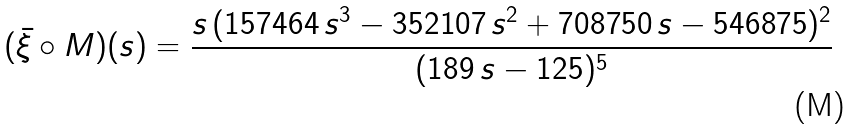Convert formula to latex. <formula><loc_0><loc_0><loc_500><loc_500>( \bar { \xi } \circ M ) ( s ) = \frac { s \, ( 1 5 7 4 6 4 \, s ^ { 3 } - 3 5 2 1 0 7 \, s ^ { 2 } + 7 0 8 7 5 0 \, s - 5 4 6 8 7 5 ) ^ { 2 } } { ( 1 8 9 \, s - 1 2 5 ) ^ { 5 } }</formula> 